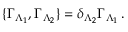<formula> <loc_0><loc_0><loc_500><loc_500>\{ \Gamma _ { \Lambda _ { 1 } } , \Gamma _ { \Lambda _ { 2 } } \} = \delta _ { \Lambda _ { 2 } } \Gamma _ { \Lambda _ { 1 } } \, .</formula> 